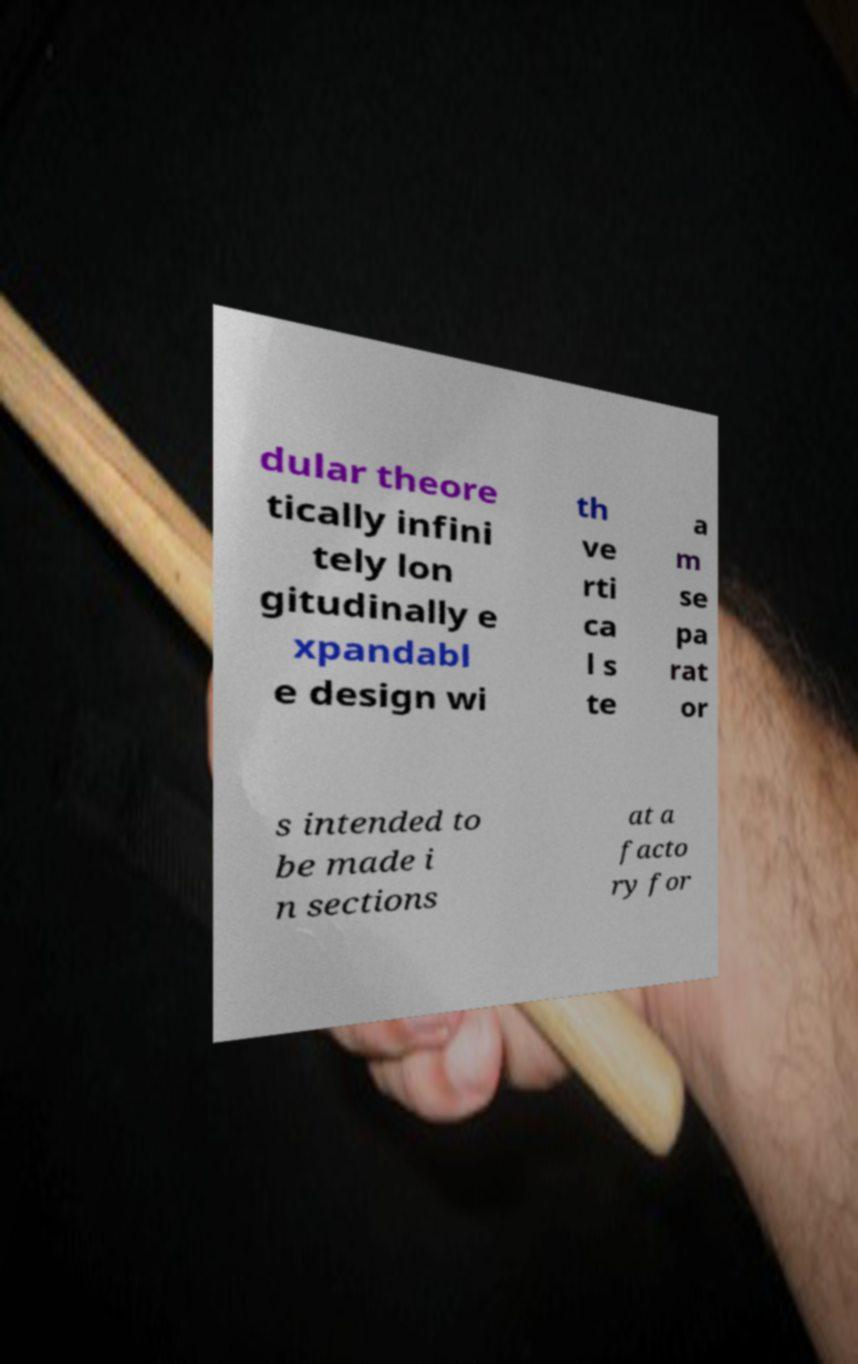Please read and relay the text visible in this image. What does it say? dular theore tically infini tely lon gitudinally e xpandabl e design wi th ve rti ca l s te a m se pa rat or s intended to be made i n sections at a facto ry for 